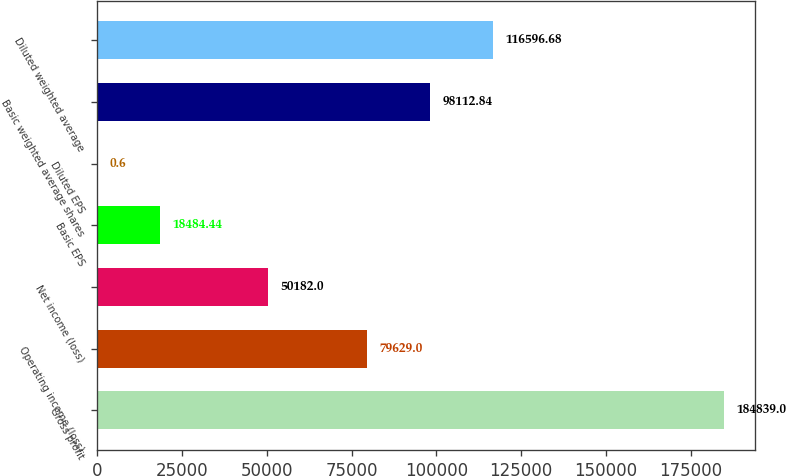<chart> <loc_0><loc_0><loc_500><loc_500><bar_chart><fcel>Gross profit<fcel>Operating income (loss)<fcel>Net income (loss)<fcel>Basic EPS<fcel>Diluted EPS<fcel>Basic weighted average shares<fcel>Diluted weighted average<nl><fcel>184839<fcel>79629<fcel>50182<fcel>18484.4<fcel>0.6<fcel>98112.8<fcel>116597<nl></chart> 